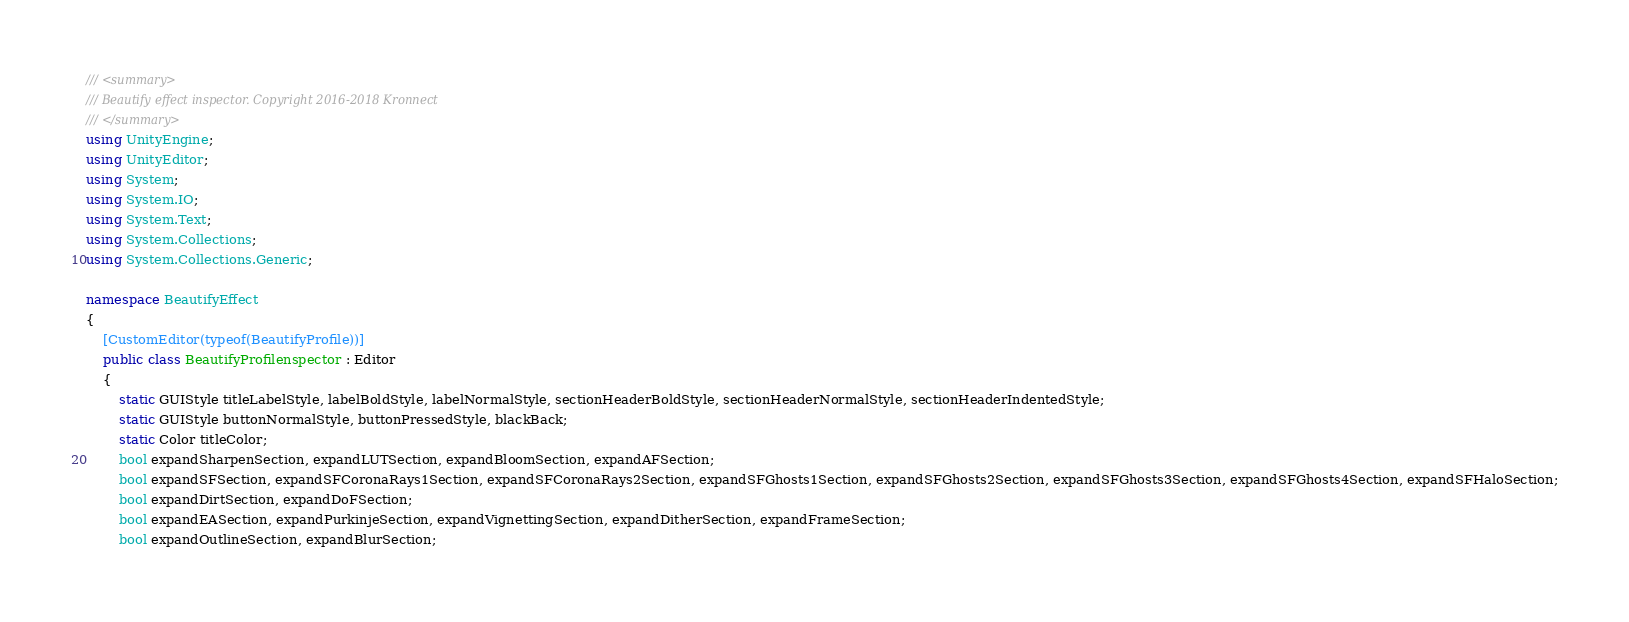Convert code to text. <code><loc_0><loc_0><loc_500><loc_500><_C#_>/// <summary>
/// Beautify effect inspector. Copyright 2016-2018 Kronnect
/// </summary>
using UnityEngine;
using UnityEditor;
using System;
using System.IO;
using System.Text;
using System.Collections;
using System.Collections.Generic;

namespace BeautifyEffect
{
    [CustomEditor(typeof(BeautifyProfile))]
    public class BeautifyProfilenspector : Editor
    {
        static GUIStyle titleLabelStyle, labelBoldStyle, labelNormalStyle, sectionHeaderBoldStyle, sectionHeaderNormalStyle, sectionHeaderIndentedStyle;
        static GUIStyle buttonNormalStyle, buttonPressedStyle, blackBack;
        static Color titleColor;
        bool expandSharpenSection, expandLUTSection, expandBloomSection, expandAFSection;
        bool expandSFSection, expandSFCoronaRays1Section, expandSFCoronaRays2Section, expandSFGhosts1Section, expandSFGhosts2Section, expandSFGhosts3Section, expandSFGhosts4Section, expandSFHaloSection;
        bool expandDirtSection, expandDoFSection;
        bool expandEASection, expandPurkinjeSection, expandVignettingSection, expandDitherSection, expandFrameSection;
        bool expandOutlineSection, expandBlurSection;</code> 